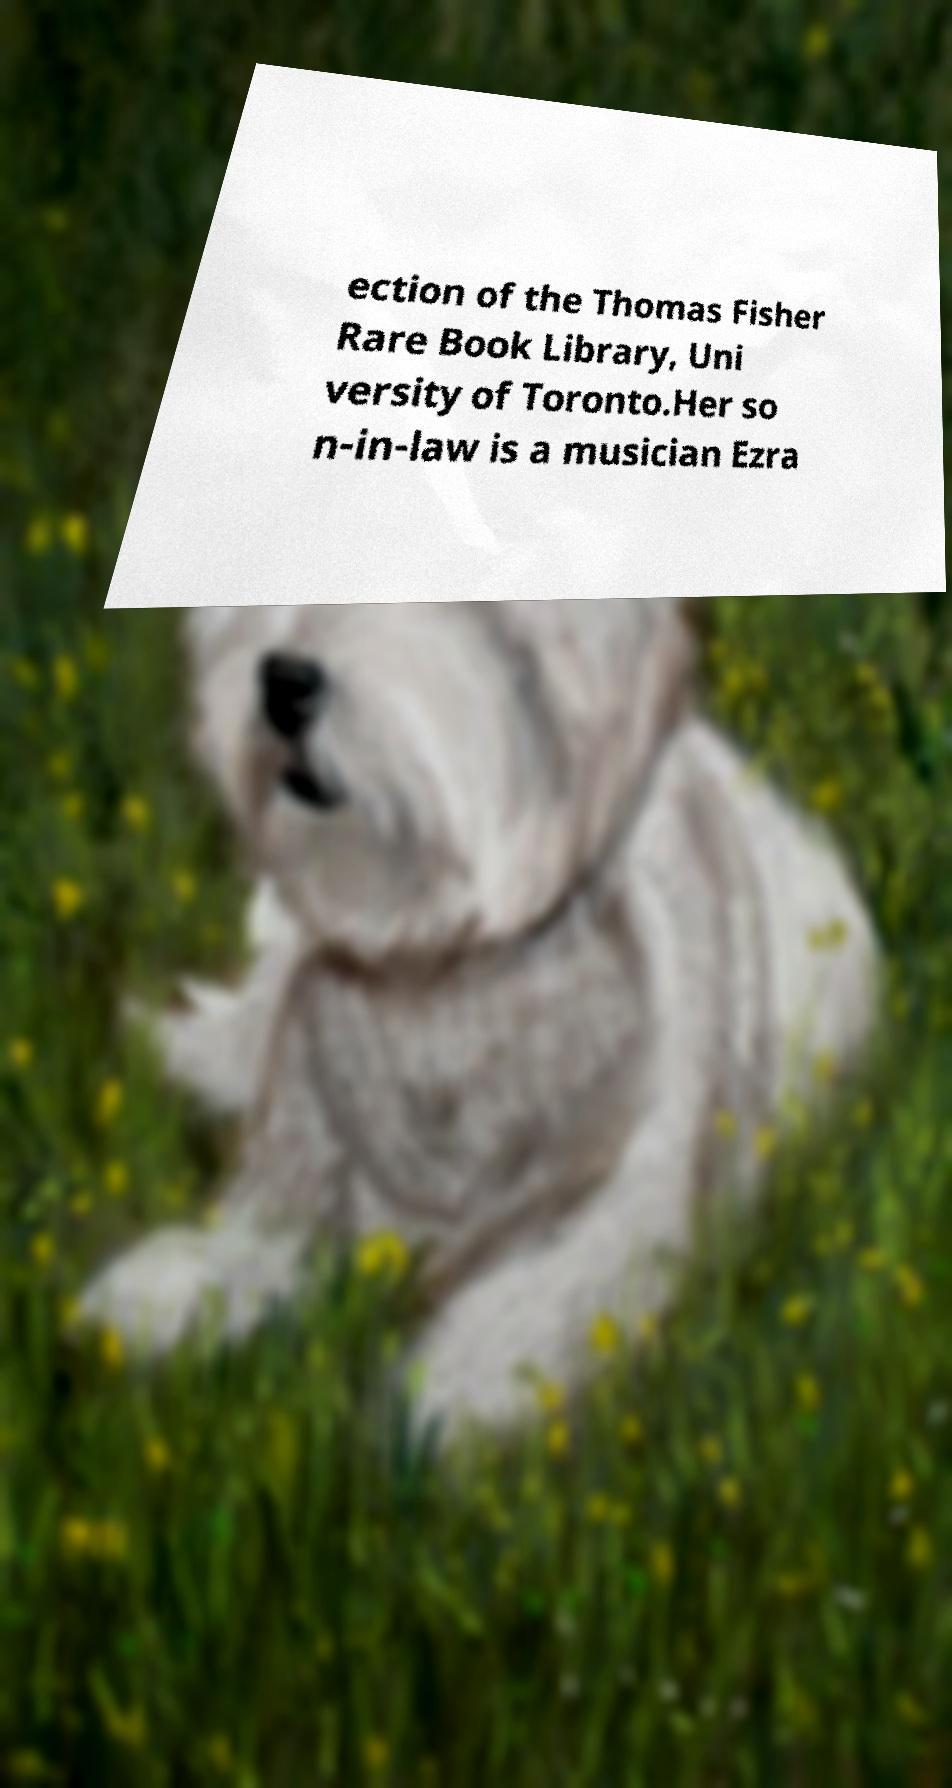For documentation purposes, I need the text within this image transcribed. Could you provide that? ection of the Thomas Fisher Rare Book Library, Uni versity of Toronto.Her so n-in-law is a musician Ezra 